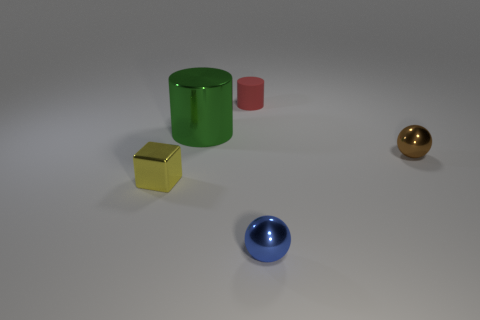What number of things are either tiny things that are in front of the metallic cylinder or tiny brown metal objects?
Offer a terse response. 3. Is the number of large green metal cylinders right of the blue shiny sphere less than the number of blue things that are in front of the red object?
Offer a terse response. Yes. How many other things are there of the same size as the shiny cylinder?
Keep it short and to the point. 0. Is the material of the yellow thing the same as the cylinder to the right of the large thing?
Keep it short and to the point. No. What number of objects are either big green shiny objects behind the small blue object or tiny things to the left of the matte thing?
Your response must be concise. 2. What color is the tiny cylinder?
Keep it short and to the point. Red. Is the number of small blue metal things behind the blue ball less than the number of small rubber cylinders?
Offer a very short reply. Yes. Is there anything else that has the same shape as the small yellow metal thing?
Ensure brevity in your answer.  No. Is there a big object?
Offer a terse response. Yes. Are there fewer green objects than tiny metallic spheres?
Ensure brevity in your answer.  Yes. 